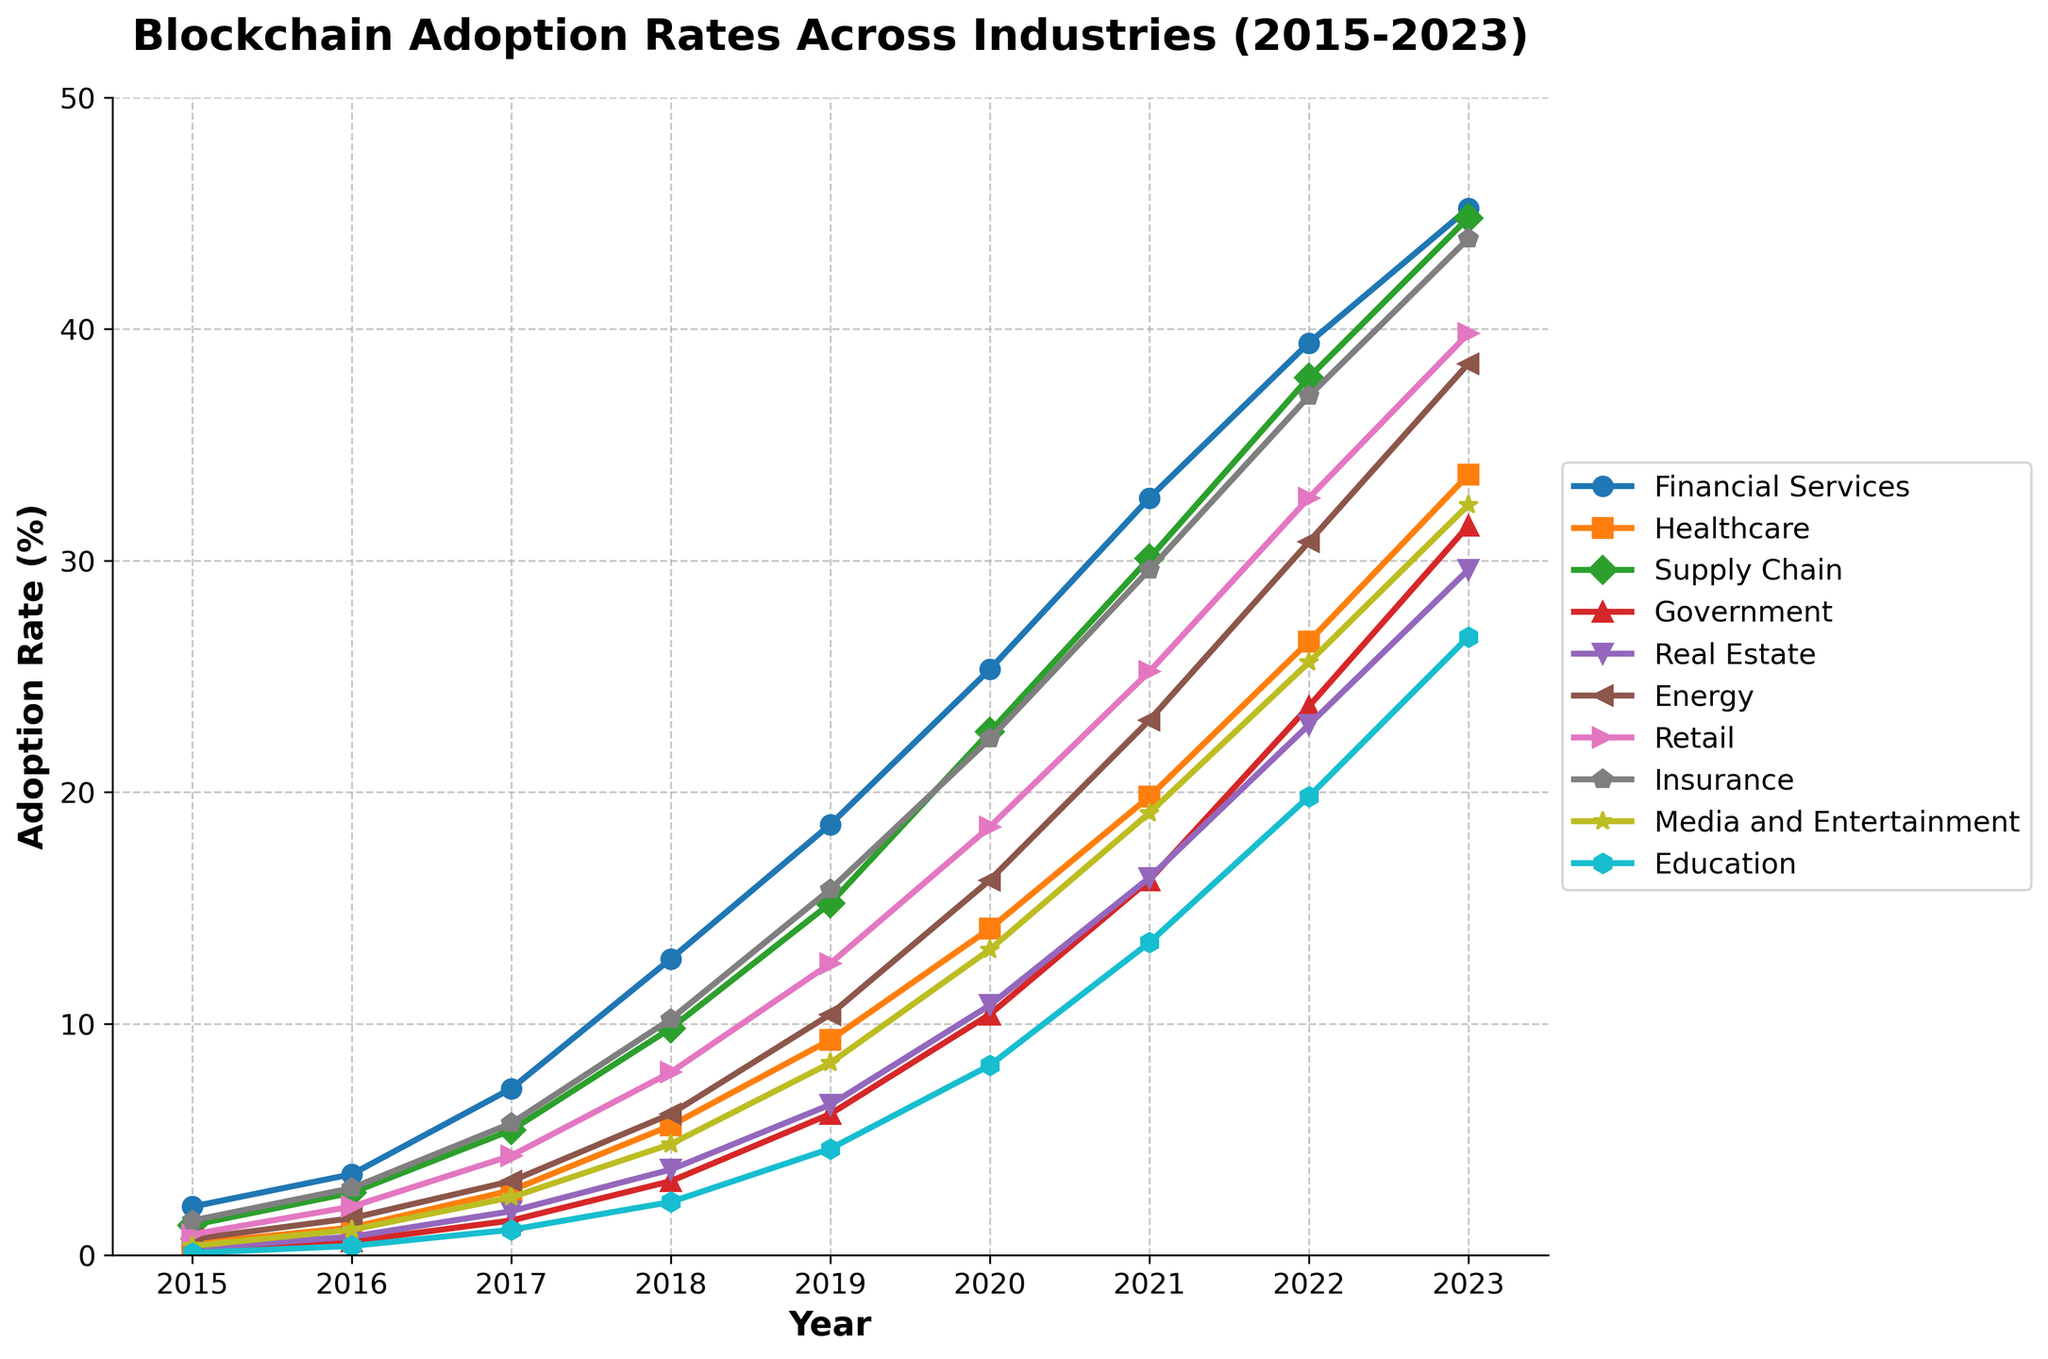What industry had the highest blockchain adoption rate in 2023? The 2023 adoption rates are displayed for each industry, and the highest value is 45.2% for Financial Services.
Answer: Financial Services Which industry had the lowest adoption rate in 2015? The adoption rates in 2015 are compared, and the lowest value is 0.1% for Education.
Answer: Education Between 2015 and 2023, which industry had the largest increase in adoption rate? Calculate the difference between the 2023 and 2015 adoption rates for each industry. Financial Services increased from 2.1% to 45.2%, a difference of 43.1%, which is the largest increase.
Answer: Financial Services How does the adoption rate of the Government sector in 2023 compare to the Retail sector in 2020? Locate the 2023 adoption rate for Government, which is 31.5%, and the 2020 adoption rate for Retail, which is 18.5%. Compare these values: 31.5% > 18.5%.
Answer: Government in 2023 has a higher adoption rate By how much did the adoption rate of Healthcare change from 2018 to 2020? The adoption rate for Healthcare is 5.6% in 2018 and 14.1% in 2020. The difference is 14.1% - 5.6% = 8.5%.
Answer: 8.5% Which industry had the most rapid growth in blockchain adoption between 2016 and 2017? Determine the differences between 2017 and 2016 adoption rates. Healthcare had the largest difference, increasing from 1.2% to 2.8%, a 1.6% increase.
Answer: Healthcare What is the average adoption rate for the Energy sector over the given years? Add the adoption rates from 2015 to 2023 for Energy and divide by the number of years: (0.7 + 1.6 + 3.2 + 6.1 + 10.4 + 16.2 + 23.1 + 30.8 + 38.5) / 9 ≈ 14.4%.
Answer: 14.4% In which year did the Media and Entertainment sector surpass a 10% adoption rate? Check the progression of the Media and Entertainment sector's adoption rates. It exceeded 10% in 2020, with a value of 13.2%.
Answer: 2020 What is the difference in adoption rates between Real Estate and Insurance in 2019? Find the adoption rates for Real Estate (6.5%) and Insurance (15.8%) in 2019, and subtract: 15.8% - 6.5% = 9.3%.
Answer: 9.3% Identify the two industries with the closest adoption rates in 2022 and state their values. Compare the 2022 adoption rates for all industries and identify the closest pair. Retail (32.7%) and Media and Entertainment (32.4%) have a difference of 0.3%.
Answer: Retail (32.7%) and Media and Entertainment (32.4%) 